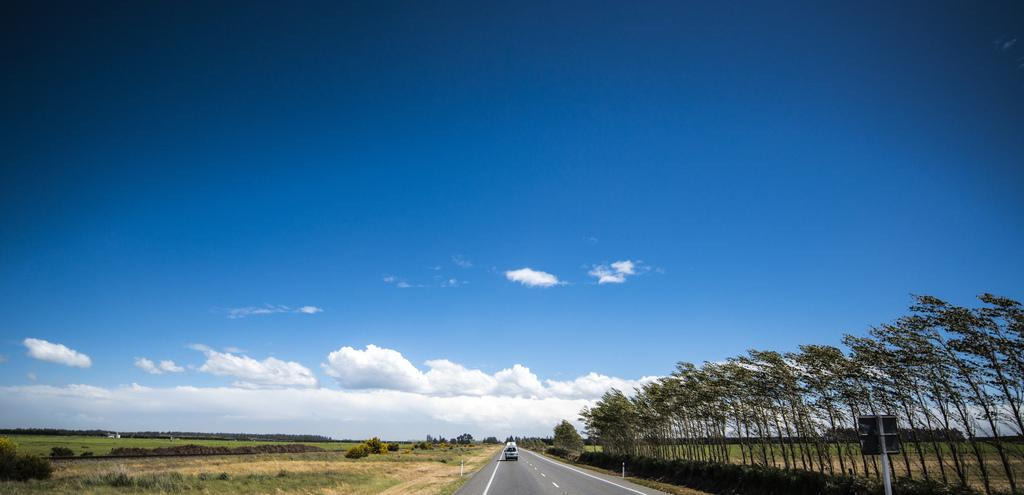What is the main subject of the image? There is a vehicle on the road in the image. What can be seen in the surroundings of the vehicle? Trees and plants are visible in the image. What is attached to a pole in the bottom right side of the image? There is a board attached to a pole in the bottom right side of the image. What is visible in the background of the image? The sky is visible in the background of the image. What type lace can be seen in the image? There is no lace present in the image. 